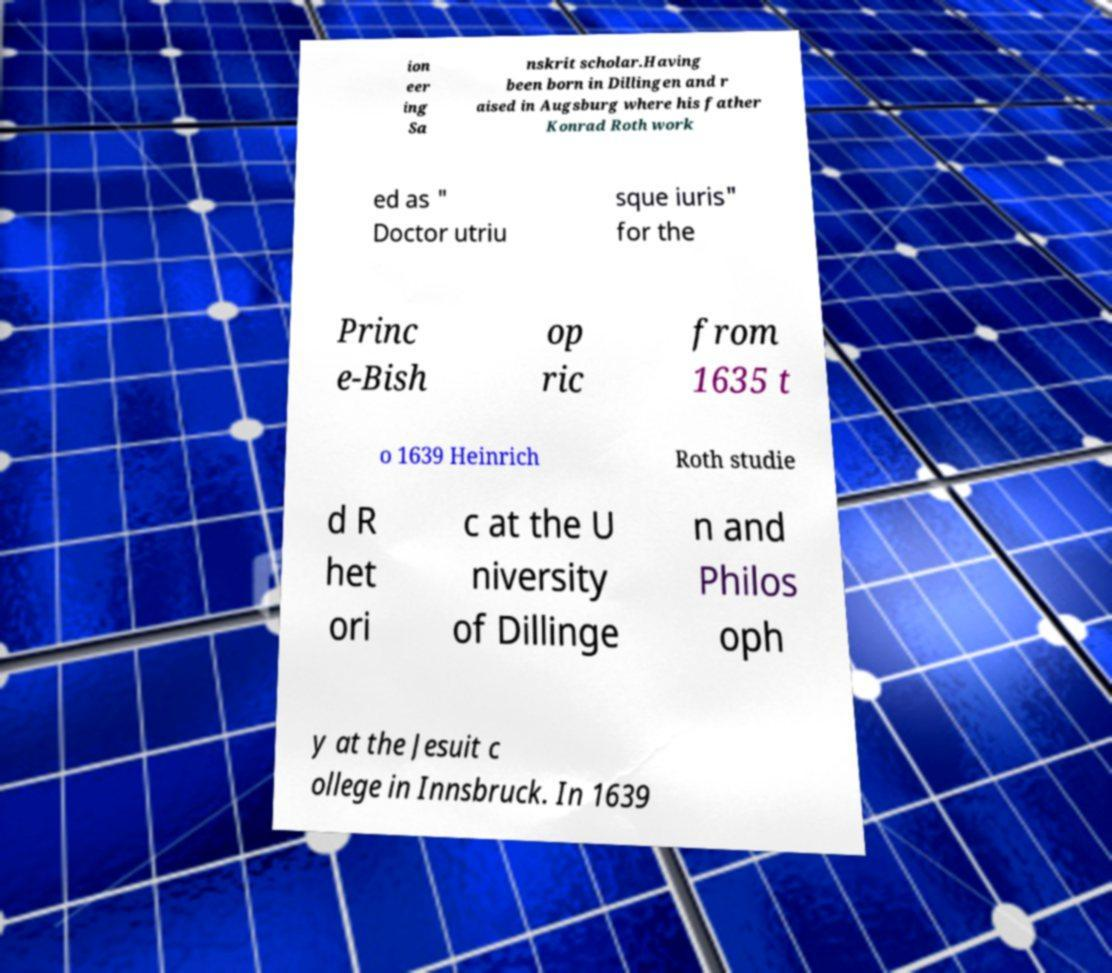Could you assist in decoding the text presented in this image and type it out clearly? ion eer ing Sa nskrit scholar.Having been born in Dillingen and r aised in Augsburg where his father Konrad Roth work ed as " Doctor utriu sque iuris" for the Princ e-Bish op ric from 1635 t o 1639 Heinrich Roth studie d R het ori c at the U niversity of Dillinge n and Philos oph y at the Jesuit c ollege in Innsbruck. In 1639 